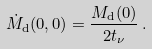<formula> <loc_0><loc_0><loc_500><loc_500>\dot { M } _ { \mathrm d } ( 0 , 0 ) = \frac { M _ { \mathrm d } ( 0 ) } { 2 t _ { \nu } } \, .</formula> 